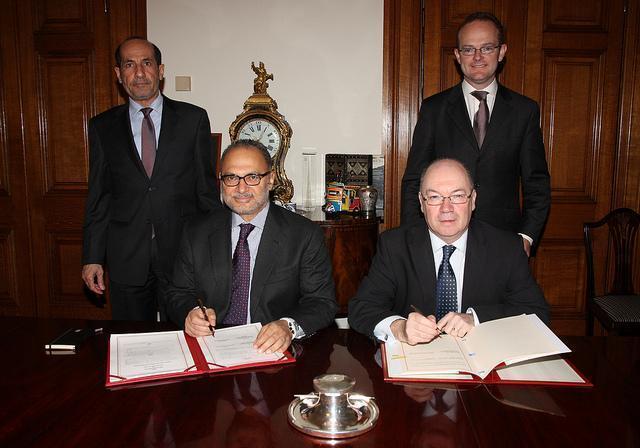What type of event is this?
Pick the right solution, then justify: 'Answer: answer
Rationale: rationale.'
Options: Meeting, funeral, shower, wedding. Answer: meeting.
Rationale: The men are in a business meeting. 